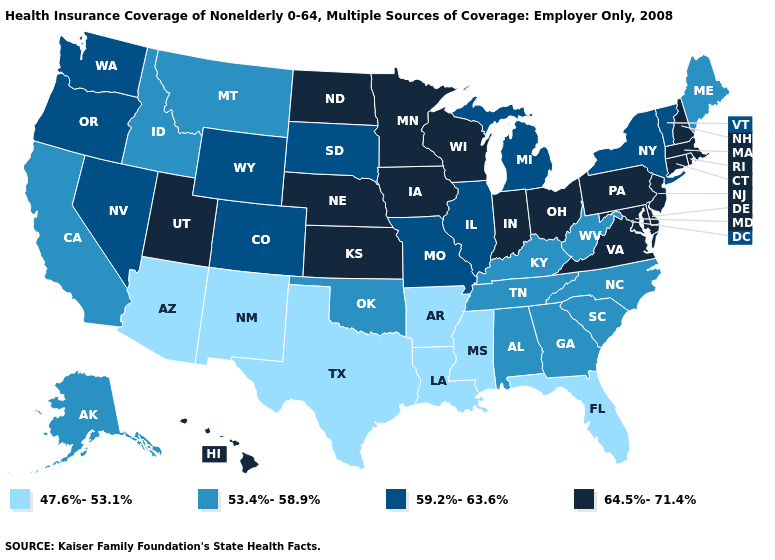How many symbols are there in the legend?
Concise answer only. 4. Among the states that border Wyoming , which have the highest value?
Quick response, please. Nebraska, Utah. Does California have a higher value than Idaho?
Give a very brief answer. No. Name the states that have a value in the range 64.5%-71.4%?
Short answer required. Connecticut, Delaware, Hawaii, Indiana, Iowa, Kansas, Maryland, Massachusetts, Minnesota, Nebraska, New Hampshire, New Jersey, North Dakota, Ohio, Pennsylvania, Rhode Island, Utah, Virginia, Wisconsin. Does the first symbol in the legend represent the smallest category?
Answer briefly. Yes. What is the highest value in states that border Vermont?
Answer briefly. 64.5%-71.4%. What is the lowest value in the South?
Give a very brief answer. 47.6%-53.1%. Name the states that have a value in the range 59.2%-63.6%?
Write a very short answer. Colorado, Illinois, Michigan, Missouri, Nevada, New York, Oregon, South Dakota, Vermont, Washington, Wyoming. What is the highest value in the South ?
Give a very brief answer. 64.5%-71.4%. What is the value of Georgia?
Concise answer only. 53.4%-58.9%. What is the value of Utah?
Keep it brief. 64.5%-71.4%. Which states hav the highest value in the Northeast?
Concise answer only. Connecticut, Massachusetts, New Hampshire, New Jersey, Pennsylvania, Rhode Island. Which states have the highest value in the USA?
Concise answer only. Connecticut, Delaware, Hawaii, Indiana, Iowa, Kansas, Maryland, Massachusetts, Minnesota, Nebraska, New Hampshire, New Jersey, North Dakota, Ohio, Pennsylvania, Rhode Island, Utah, Virginia, Wisconsin. What is the lowest value in the USA?
Give a very brief answer. 47.6%-53.1%. What is the value of New York?
Short answer required. 59.2%-63.6%. 